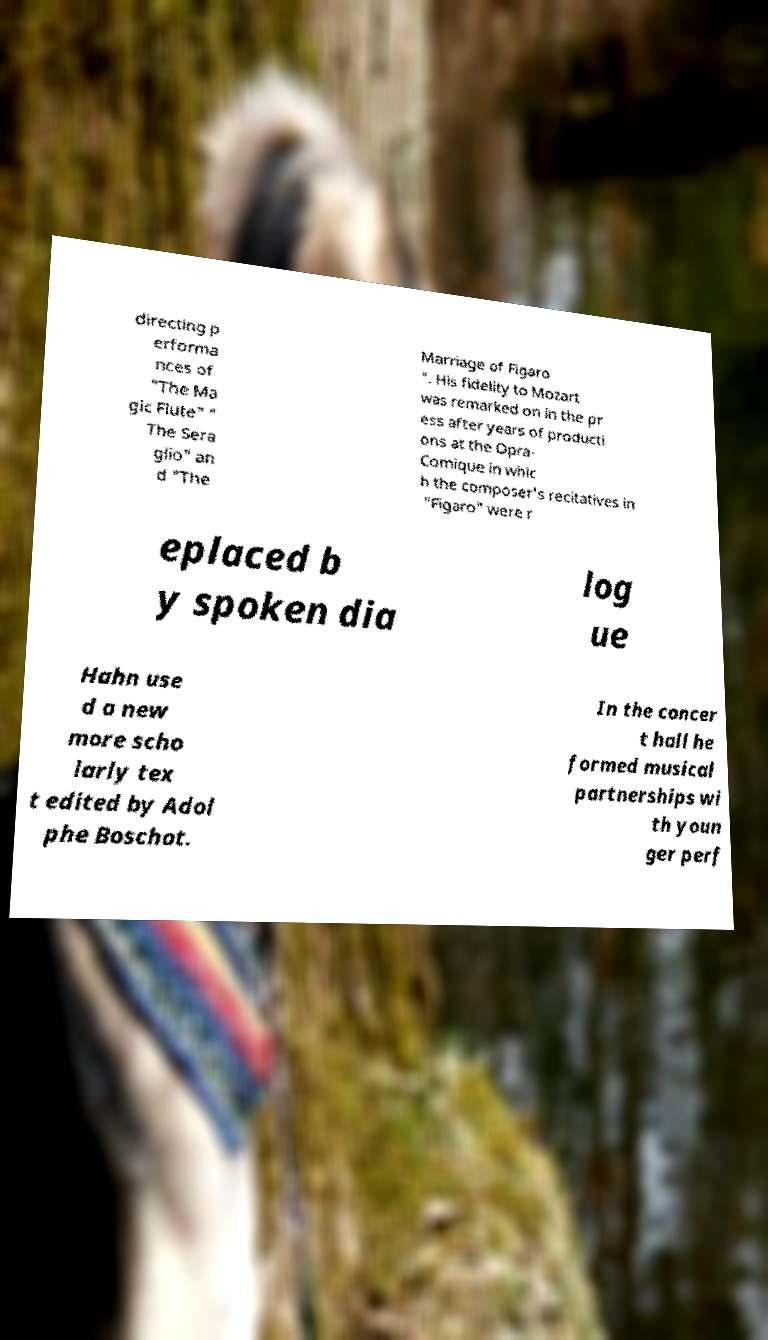Can you accurately transcribe the text from the provided image for me? directing p erforma nces of "The Ma gic Flute" " The Sera glio" an d "The Marriage of Figaro ". His fidelity to Mozart was remarked on in the pr ess after years of producti ons at the Opra- Comique in whic h the composer's recitatives in "Figaro" were r eplaced b y spoken dia log ue Hahn use d a new more scho larly tex t edited by Adol phe Boschot. In the concer t hall he formed musical partnerships wi th youn ger perf 